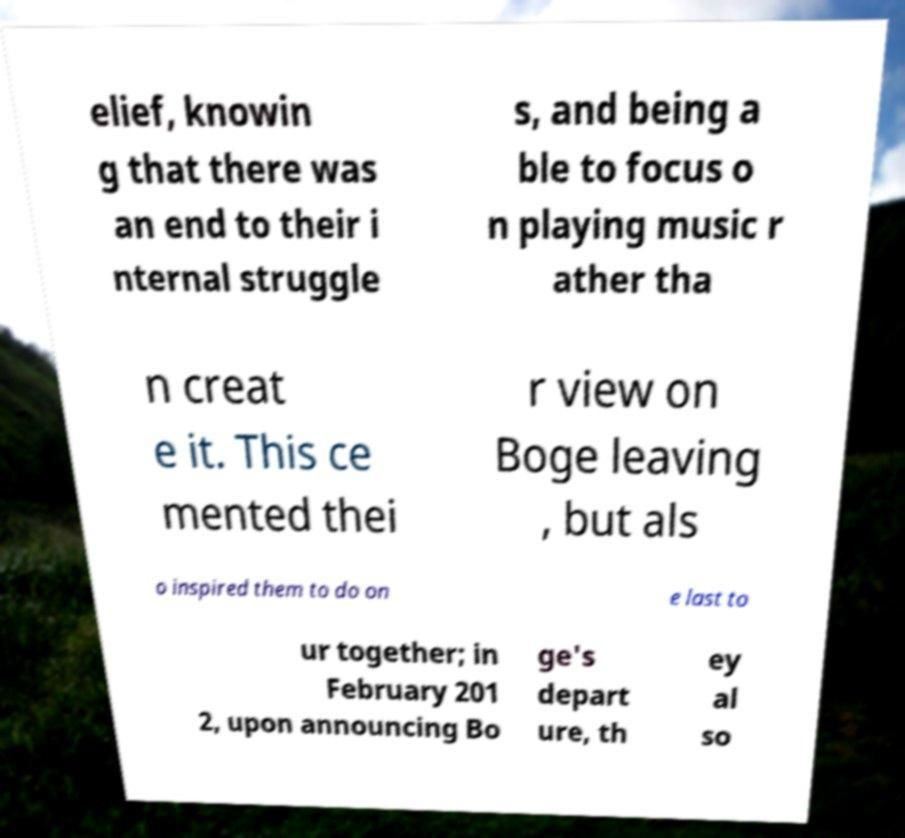Please read and relay the text visible in this image. What does it say? elief, knowin g that there was an end to their i nternal struggle s, and being a ble to focus o n playing music r ather tha n creat e it. This ce mented thei r view on Boge leaving , but als o inspired them to do on e last to ur together; in February 201 2, upon announcing Bo ge's depart ure, th ey al so 